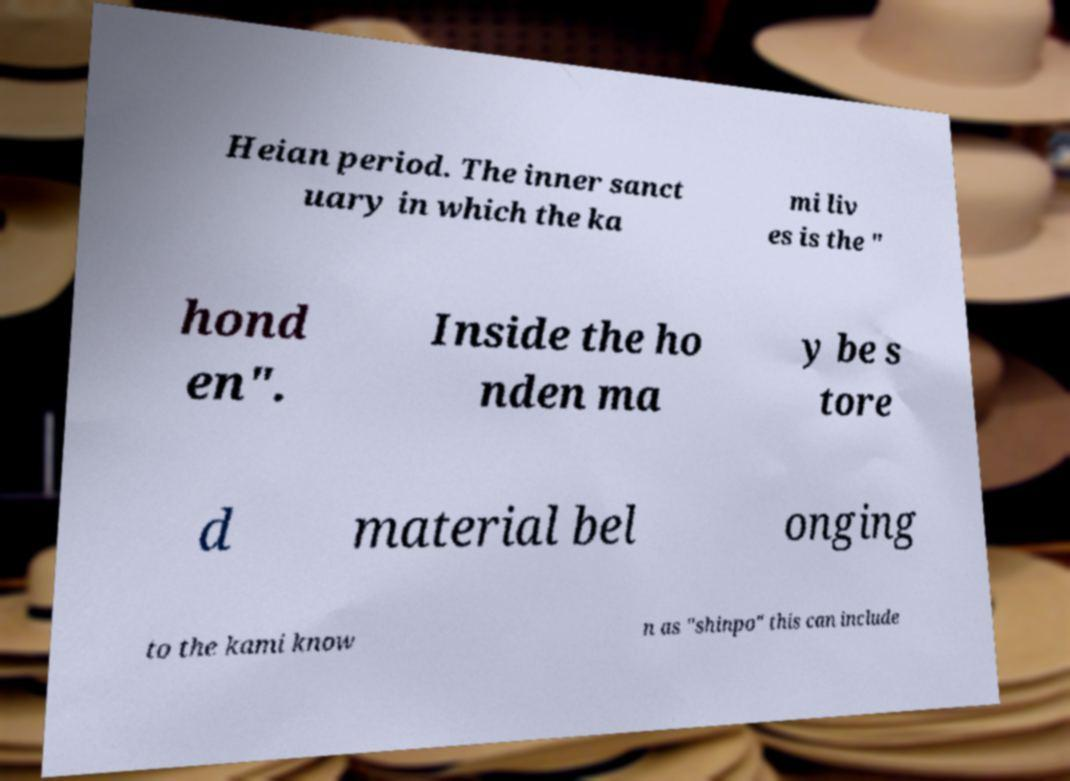Can you read and provide the text displayed in the image?This photo seems to have some interesting text. Can you extract and type it out for me? Heian period. The inner sanct uary in which the ka mi liv es is the " hond en". Inside the ho nden ma y be s tore d material bel onging to the kami know n as "shinpo" this can include 